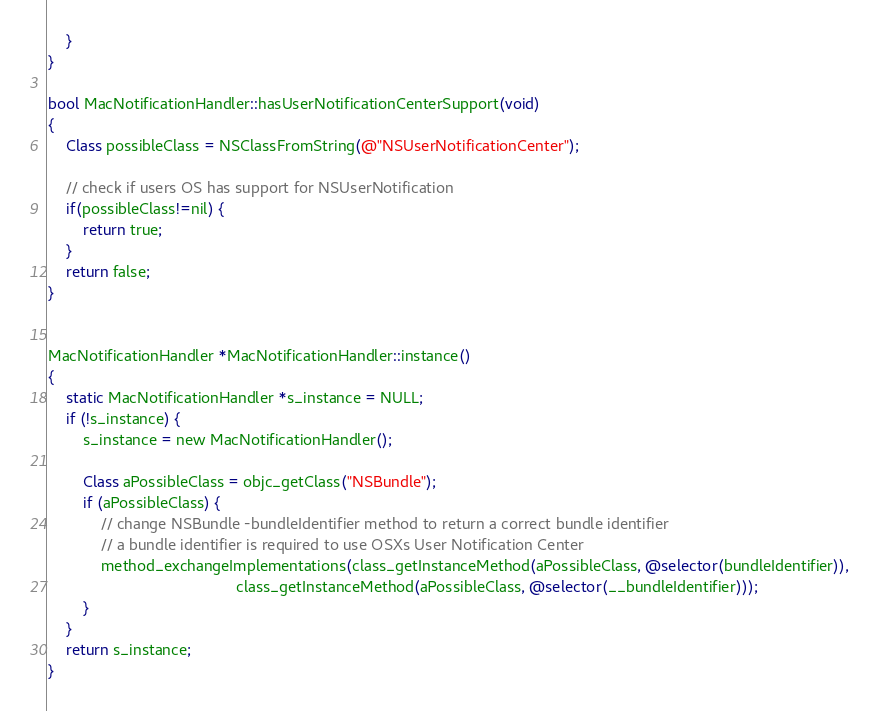Convert code to text. <code><loc_0><loc_0><loc_500><loc_500><_ObjectiveC_>    }
}

bool MacNotificationHandler::hasUserNotificationCenterSupport(void)
{
    Class possibleClass = NSClassFromString(@"NSUserNotificationCenter");

    // check if users OS has support for NSUserNotification
    if(possibleClass!=nil) {
        return true;
    }
    return false;
}


MacNotificationHandler *MacNotificationHandler::instance()
{
    static MacNotificationHandler *s_instance = NULL;
    if (!s_instance) {
        s_instance = new MacNotificationHandler();
        
        Class aPossibleClass = objc_getClass("NSBundle");
        if (aPossibleClass) {
            // change NSBundle -bundleIdentifier method to return a correct bundle identifier
            // a bundle identifier is required to use OSXs User Notification Center
            method_exchangeImplementations(class_getInstanceMethod(aPossibleClass, @selector(bundleIdentifier)),
                                           class_getInstanceMethod(aPossibleClass, @selector(__bundleIdentifier)));
        }
    }
    return s_instance;
}
</code> 